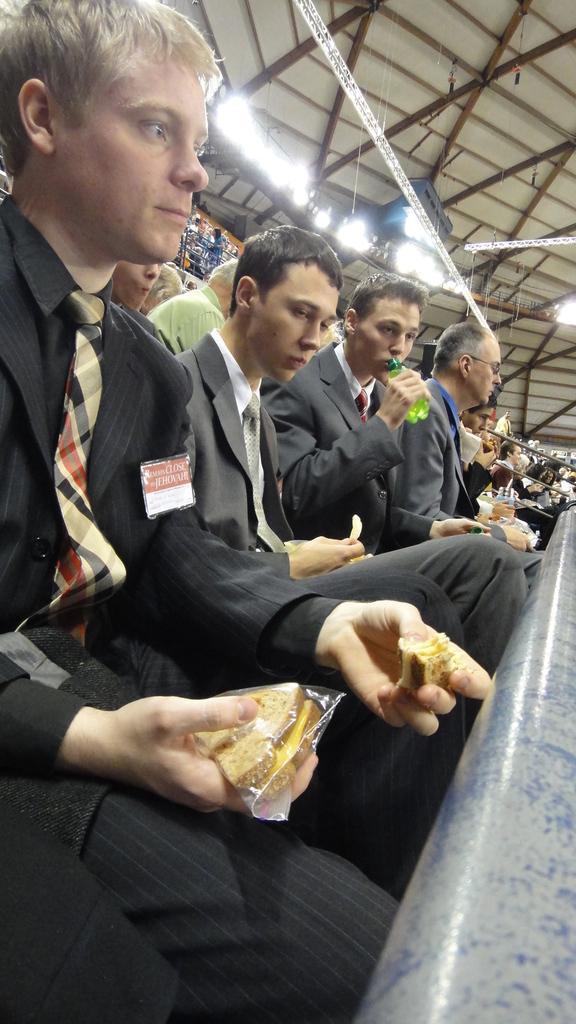In one or two sentences, can you explain what this image depicts? In this image I can see group of people sitting. There are few people holding food items. In the bottom right corner it looks like a pole. There is roof with iron frames and there are lights. 